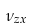Convert formula to latex. <formula><loc_0><loc_0><loc_500><loc_500>\nu _ { z x }</formula> 